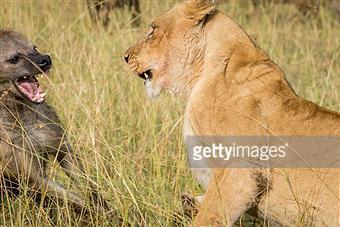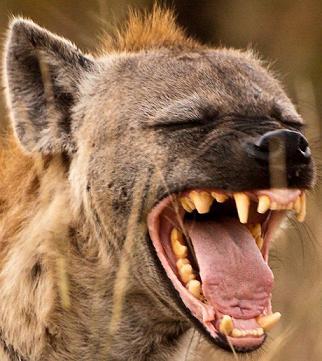The first image is the image on the left, the second image is the image on the right. Considering the images on both sides, is "The right image contains at least two animals." valid? Answer yes or no. No. The first image is the image on the left, the second image is the image on the right. Assess this claim about the two images: "The lefthand image includes a lion, and the righthand image contains only a fang-baring hyena.". Correct or not? Answer yes or no. Yes. 